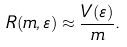<formula> <loc_0><loc_0><loc_500><loc_500>R ( m , \varepsilon ) \approx \frac { V ( \varepsilon ) } { m } .</formula> 